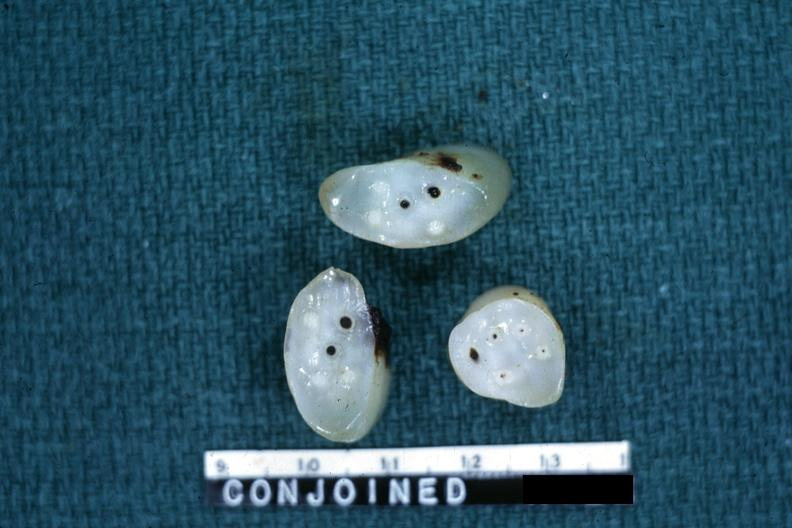what is present?
Answer the question using a single word or phrase. Female reproductive 